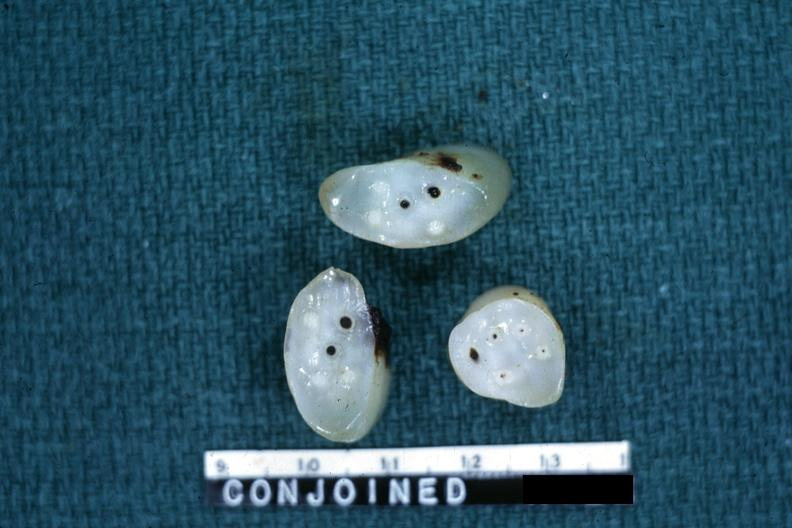what is present?
Answer the question using a single word or phrase. Female reproductive 